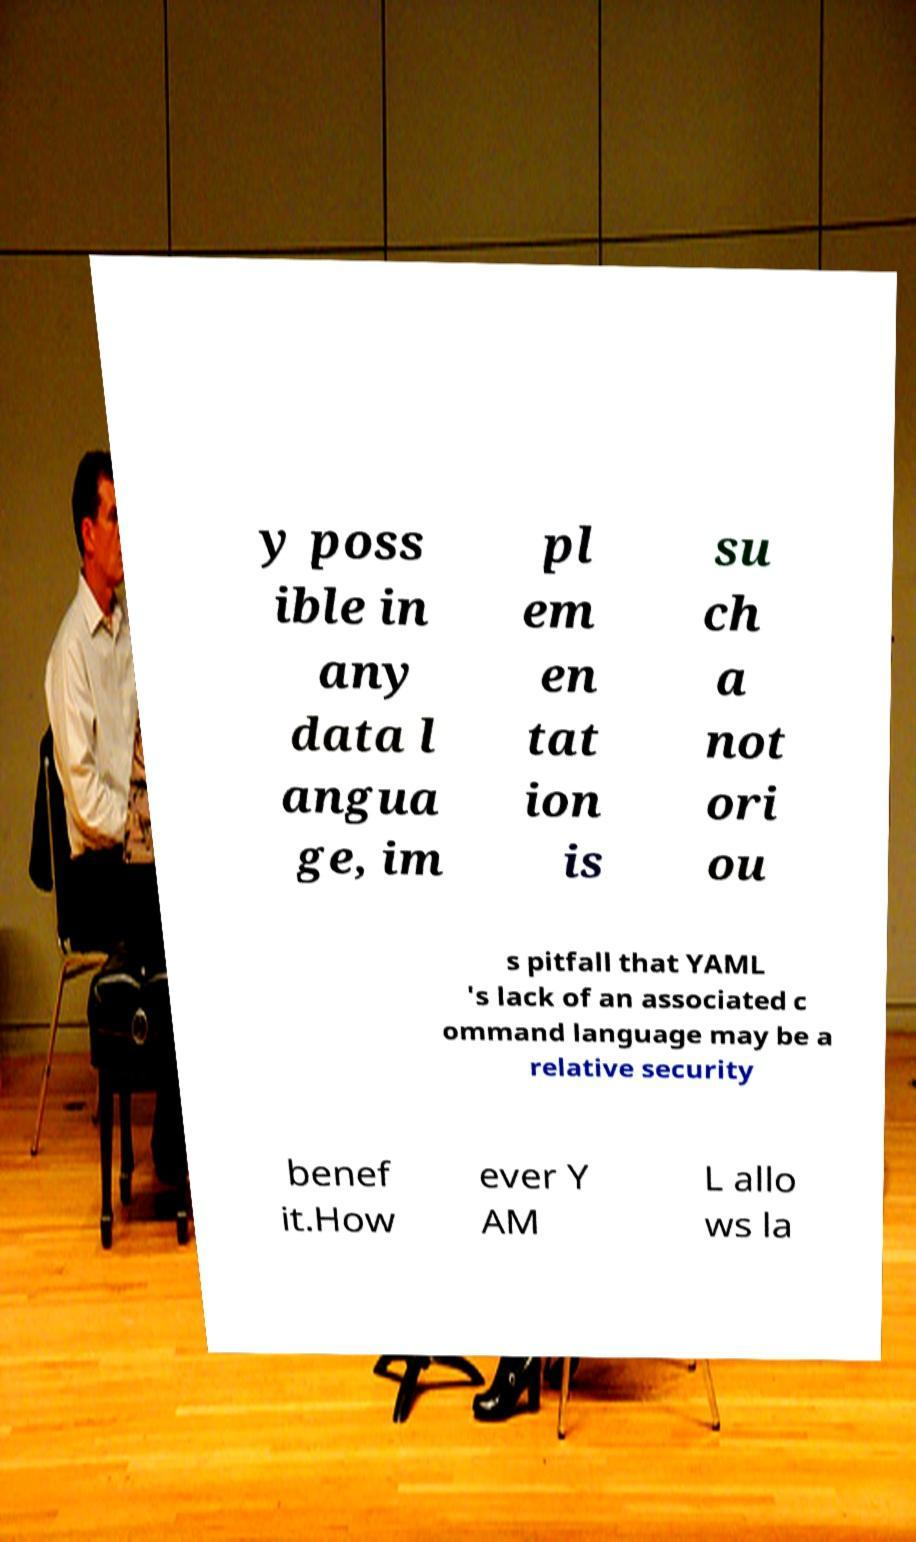There's text embedded in this image that I need extracted. Can you transcribe it verbatim? y poss ible in any data l angua ge, im pl em en tat ion is su ch a not ori ou s pitfall that YAML 's lack of an associated c ommand language may be a relative security benef it.How ever Y AM L allo ws la 